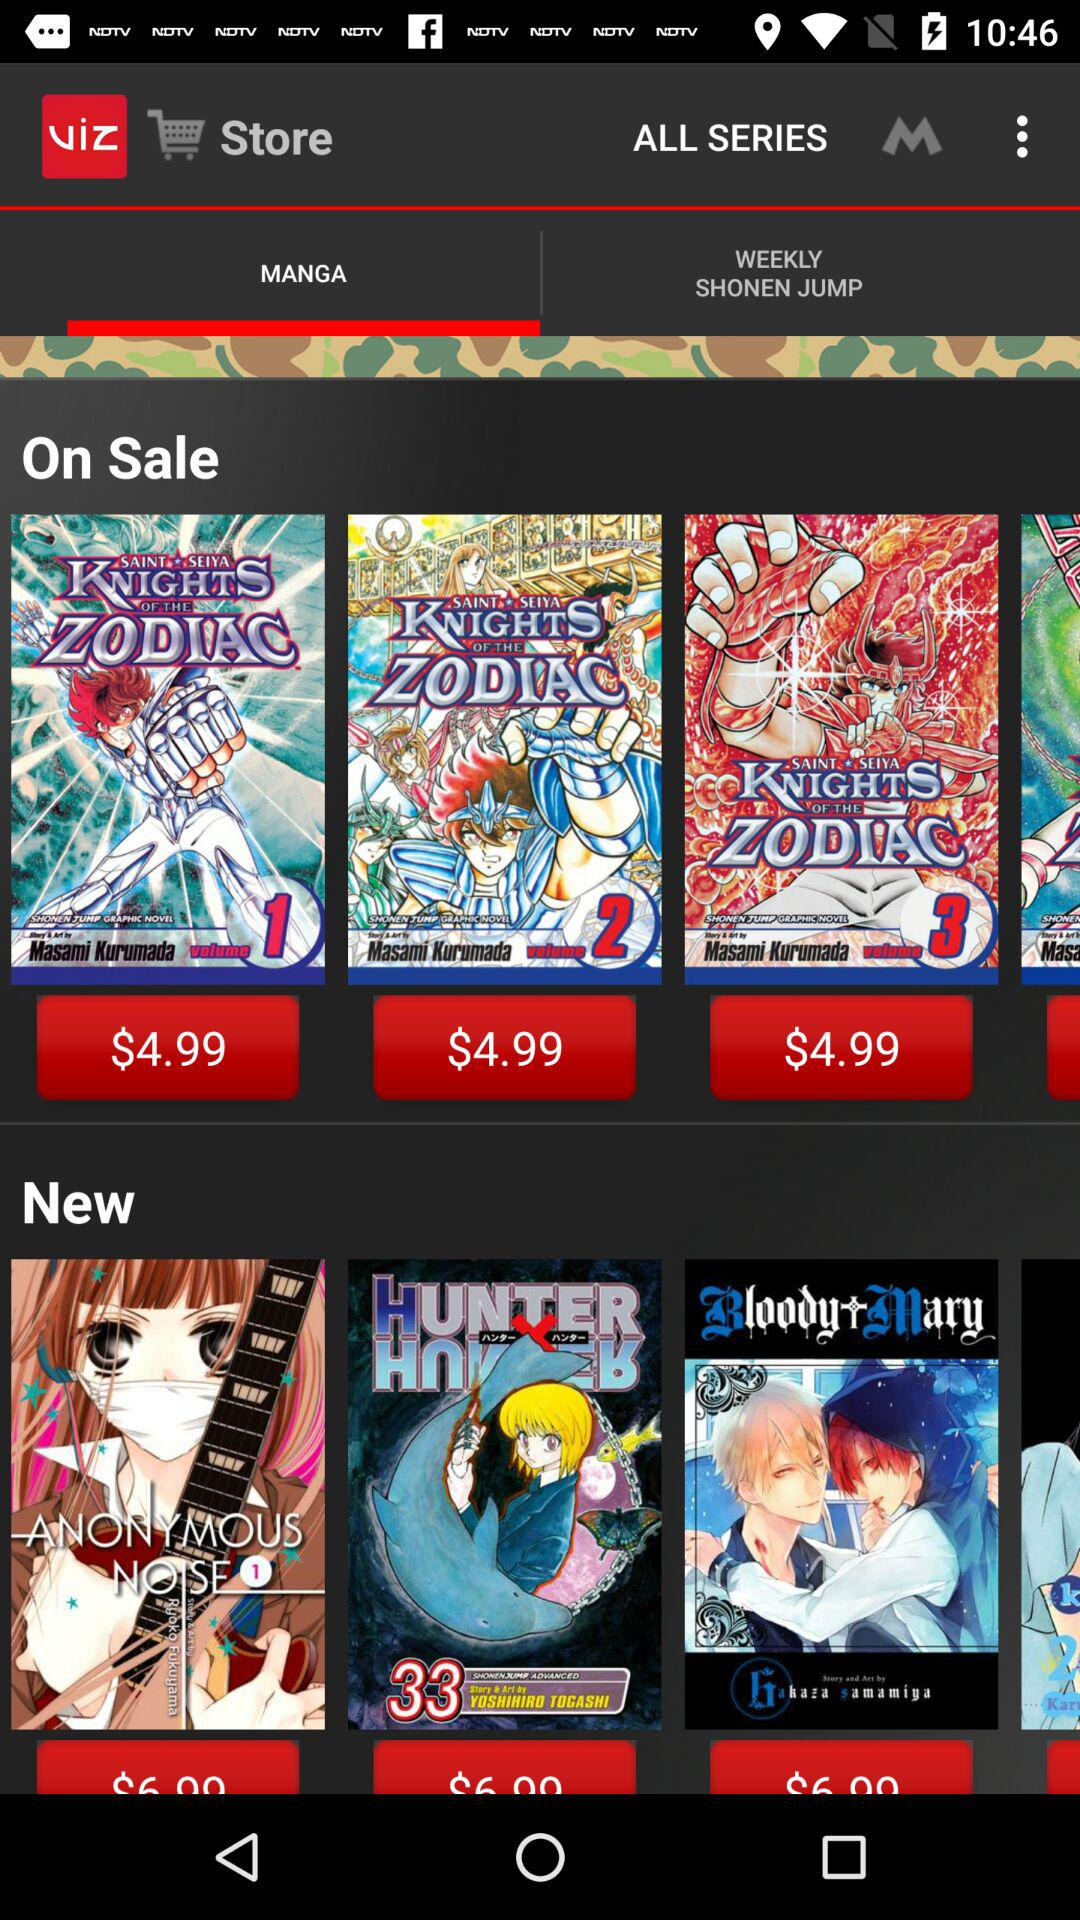Which tab is selected? The selected tab is "MANGA". 